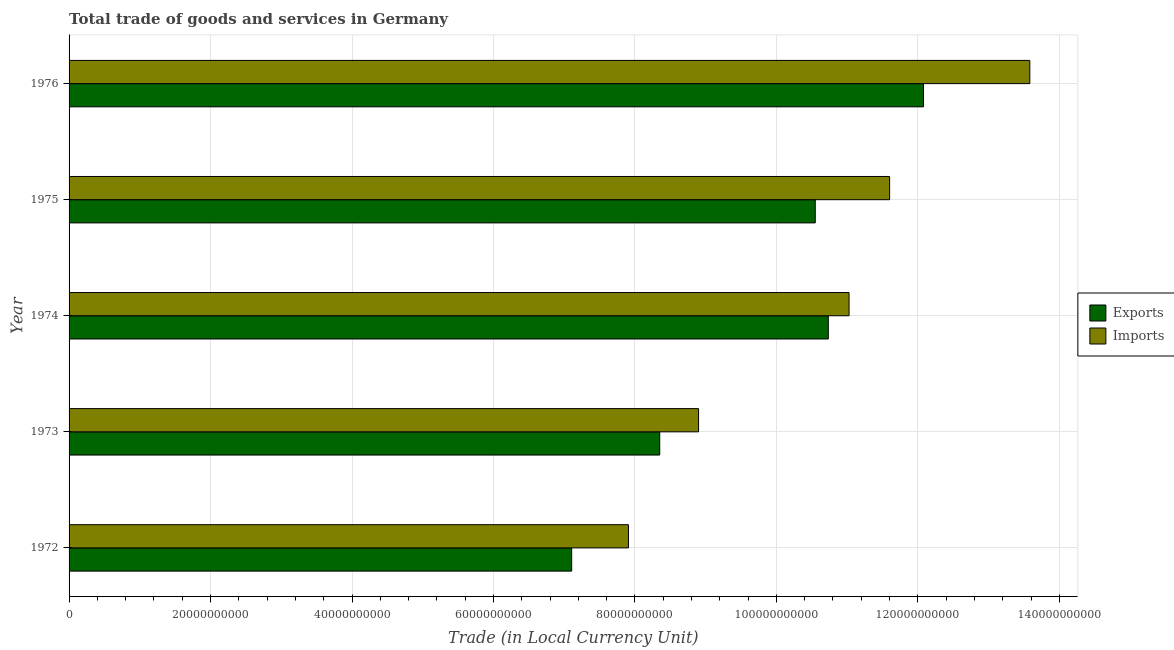How many different coloured bars are there?
Offer a terse response. 2. How many groups of bars are there?
Your answer should be very brief. 5. Are the number of bars on each tick of the Y-axis equal?
Ensure brevity in your answer.  Yes. What is the label of the 3rd group of bars from the top?
Keep it short and to the point. 1974. What is the imports of goods and services in 1974?
Keep it short and to the point. 1.10e+11. Across all years, what is the maximum imports of goods and services?
Give a very brief answer. 1.36e+11. Across all years, what is the minimum imports of goods and services?
Provide a succinct answer. 7.91e+1. In which year was the export of goods and services maximum?
Your answer should be very brief. 1976. What is the total export of goods and services in the graph?
Offer a very short reply. 4.88e+11. What is the difference between the export of goods and services in 1972 and that in 1974?
Your response must be concise. -3.63e+1. What is the difference between the export of goods and services in 1976 and the imports of goods and services in 1973?
Your answer should be compact. 3.18e+1. What is the average export of goods and services per year?
Your answer should be very brief. 9.76e+1. In the year 1976, what is the difference between the imports of goods and services and export of goods and services?
Offer a very short reply. 1.50e+1. In how many years, is the export of goods and services greater than 8000000000 LCU?
Your answer should be compact. 5. What is the ratio of the imports of goods and services in 1974 to that in 1976?
Offer a terse response. 0.81. Is the imports of goods and services in 1973 less than that in 1975?
Ensure brevity in your answer.  Yes. What is the difference between the highest and the second highest export of goods and services?
Keep it short and to the point. 1.35e+1. What is the difference between the highest and the lowest imports of goods and services?
Ensure brevity in your answer.  5.67e+1. What does the 2nd bar from the top in 1974 represents?
Provide a succinct answer. Exports. What does the 2nd bar from the bottom in 1976 represents?
Ensure brevity in your answer.  Imports. Are all the bars in the graph horizontal?
Make the answer very short. Yes. What is the difference between two consecutive major ticks on the X-axis?
Offer a very short reply. 2.00e+1. Does the graph contain any zero values?
Your answer should be compact. No. Where does the legend appear in the graph?
Give a very brief answer. Center right. How are the legend labels stacked?
Provide a short and direct response. Vertical. What is the title of the graph?
Offer a very short reply. Total trade of goods and services in Germany. Does "Merchandise exports" appear as one of the legend labels in the graph?
Keep it short and to the point. No. What is the label or title of the X-axis?
Your response must be concise. Trade (in Local Currency Unit). What is the Trade (in Local Currency Unit) of Exports in 1972?
Your answer should be compact. 7.11e+1. What is the Trade (in Local Currency Unit) in Imports in 1972?
Your answer should be very brief. 7.91e+1. What is the Trade (in Local Currency Unit) of Exports in 1973?
Your answer should be compact. 8.35e+1. What is the Trade (in Local Currency Unit) of Imports in 1973?
Your response must be concise. 8.90e+1. What is the Trade (in Local Currency Unit) of Exports in 1974?
Your answer should be compact. 1.07e+11. What is the Trade (in Local Currency Unit) in Imports in 1974?
Give a very brief answer. 1.10e+11. What is the Trade (in Local Currency Unit) in Exports in 1975?
Keep it short and to the point. 1.05e+11. What is the Trade (in Local Currency Unit) of Imports in 1975?
Keep it short and to the point. 1.16e+11. What is the Trade (in Local Currency Unit) in Exports in 1976?
Your answer should be compact. 1.21e+11. What is the Trade (in Local Currency Unit) of Imports in 1976?
Ensure brevity in your answer.  1.36e+11. Across all years, what is the maximum Trade (in Local Currency Unit) in Exports?
Offer a very short reply. 1.21e+11. Across all years, what is the maximum Trade (in Local Currency Unit) of Imports?
Your response must be concise. 1.36e+11. Across all years, what is the minimum Trade (in Local Currency Unit) of Exports?
Offer a very short reply. 7.11e+1. Across all years, what is the minimum Trade (in Local Currency Unit) of Imports?
Make the answer very short. 7.91e+1. What is the total Trade (in Local Currency Unit) in Exports in the graph?
Provide a succinct answer. 4.88e+11. What is the total Trade (in Local Currency Unit) in Imports in the graph?
Offer a terse response. 5.30e+11. What is the difference between the Trade (in Local Currency Unit) of Exports in 1972 and that in 1973?
Ensure brevity in your answer.  -1.24e+1. What is the difference between the Trade (in Local Currency Unit) of Imports in 1972 and that in 1973?
Provide a succinct answer. -9.91e+09. What is the difference between the Trade (in Local Currency Unit) of Exports in 1972 and that in 1974?
Give a very brief answer. -3.63e+1. What is the difference between the Trade (in Local Currency Unit) in Imports in 1972 and that in 1974?
Keep it short and to the point. -3.12e+1. What is the difference between the Trade (in Local Currency Unit) in Exports in 1972 and that in 1975?
Keep it short and to the point. -3.44e+1. What is the difference between the Trade (in Local Currency Unit) in Imports in 1972 and that in 1975?
Ensure brevity in your answer.  -3.69e+1. What is the difference between the Trade (in Local Currency Unit) in Exports in 1972 and that in 1976?
Your answer should be very brief. -4.97e+1. What is the difference between the Trade (in Local Currency Unit) of Imports in 1972 and that in 1976?
Your answer should be compact. -5.67e+1. What is the difference between the Trade (in Local Currency Unit) in Exports in 1973 and that in 1974?
Your answer should be very brief. -2.38e+1. What is the difference between the Trade (in Local Currency Unit) of Imports in 1973 and that in 1974?
Offer a very short reply. -2.13e+1. What is the difference between the Trade (in Local Currency Unit) in Exports in 1973 and that in 1975?
Offer a very short reply. -2.20e+1. What is the difference between the Trade (in Local Currency Unit) of Imports in 1973 and that in 1975?
Offer a terse response. -2.70e+1. What is the difference between the Trade (in Local Currency Unit) in Exports in 1973 and that in 1976?
Offer a terse response. -3.73e+1. What is the difference between the Trade (in Local Currency Unit) of Imports in 1973 and that in 1976?
Your answer should be very brief. -4.68e+1. What is the difference between the Trade (in Local Currency Unit) in Exports in 1974 and that in 1975?
Your answer should be very brief. 1.84e+09. What is the difference between the Trade (in Local Currency Unit) in Imports in 1974 and that in 1975?
Provide a succinct answer. -5.73e+09. What is the difference between the Trade (in Local Currency Unit) of Exports in 1974 and that in 1976?
Offer a very short reply. -1.35e+1. What is the difference between the Trade (in Local Currency Unit) of Imports in 1974 and that in 1976?
Ensure brevity in your answer.  -2.56e+1. What is the difference between the Trade (in Local Currency Unit) of Exports in 1975 and that in 1976?
Offer a very short reply. -1.53e+1. What is the difference between the Trade (in Local Currency Unit) in Imports in 1975 and that in 1976?
Ensure brevity in your answer.  -1.98e+1. What is the difference between the Trade (in Local Currency Unit) in Exports in 1972 and the Trade (in Local Currency Unit) in Imports in 1973?
Your answer should be compact. -1.79e+1. What is the difference between the Trade (in Local Currency Unit) of Exports in 1972 and the Trade (in Local Currency Unit) of Imports in 1974?
Your response must be concise. -3.92e+1. What is the difference between the Trade (in Local Currency Unit) of Exports in 1972 and the Trade (in Local Currency Unit) of Imports in 1975?
Give a very brief answer. -4.50e+1. What is the difference between the Trade (in Local Currency Unit) of Exports in 1972 and the Trade (in Local Currency Unit) of Imports in 1976?
Your answer should be very brief. -6.48e+1. What is the difference between the Trade (in Local Currency Unit) of Exports in 1973 and the Trade (in Local Currency Unit) of Imports in 1974?
Give a very brief answer. -2.68e+1. What is the difference between the Trade (in Local Currency Unit) of Exports in 1973 and the Trade (in Local Currency Unit) of Imports in 1975?
Make the answer very short. -3.25e+1. What is the difference between the Trade (in Local Currency Unit) in Exports in 1973 and the Trade (in Local Currency Unit) in Imports in 1976?
Your answer should be compact. -5.23e+1. What is the difference between the Trade (in Local Currency Unit) of Exports in 1974 and the Trade (in Local Currency Unit) of Imports in 1975?
Make the answer very short. -8.67e+09. What is the difference between the Trade (in Local Currency Unit) of Exports in 1974 and the Trade (in Local Currency Unit) of Imports in 1976?
Offer a terse response. -2.85e+1. What is the difference between the Trade (in Local Currency Unit) of Exports in 1975 and the Trade (in Local Currency Unit) of Imports in 1976?
Give a very brief answer. -3.03e+1. What is the average Trade (in Local Currency Unit) in Exports per year?
Your answer should be very brief. 9.76e+1. What is the average Trade (in Local Currency Unit) in Imports per year?
Provide a succinct answer. 1.06e+11. In the year 1972, what is the difference between the Trade (in Local Currency Unit) in Exports and Trade (in Local Currency Unit) in Imports?
Offer a very short reply. -8.03e+09. In the year 1973, what is the difference between the Trade (in Local Currency Unit) in Exports and Trade (in Local Currency Unit) in Imports?
Keep it short and to the point. -5.49e+09. In the year 1974, what is the difference between the Trade (in Local Currency Unit) of Exports and Trade (in Local Currency Unit) of Imports?
Give a very brief answer. -2.94e+09. In the year 1975, what is the difference between the Trade (in Local Currency Unit) in Exports and Trade (in Local Currency Unit) in Imports?
Your answer should be compact. -1.05e+1. In the year 1976, what is the difference between the Trade (in Local Currency Unit) of Exports and Trade (in Local Currency Unit) of Imports?
Give a very brief answer. -1.50e+1. What is the ratio of the Trade (in Local Currency Unit) in Exports in 1972 to that in 1973?
Make the answer very short. 0.85. What is the ratio of the Trade (in Local Currency Unit) in Imports in 1972 to that in 1973?
Your answer should be compact. 0.89. What is the ratio of the Trade (in Local Currency Unit) of Exports in 1972 to that in 1974?
Your response must be concise. 0.66. What is the ratio of the Trade (in Local Currency Unit) in Imports in 1972 to that in 1974?
Your answer should be very brief. 0.72. What is the ratio of the Trade (in Local Currency Unit) in Exports in 1972 to that in 1975?
Keep it short and to the point. 0.67. What is the ratio of the Trade (in Local Currency Unit) of Imports in 1972 to that in 1975?
Offer a very short reply. 0.68. What is the ratio of the Trade (in Local Currency Unit) of Exports in 1972 to that in 1976?
Offer a very short reply. 0.59. What is the ratio of the Trade (in Local Currency Unit) in Imports in 1972 to that in 1976?
Your answer should be very brief. 0.58. What is the ratio of the Trade (in Local Currency Unit) of Exports in 1973 to that in 1974?
Give a very brief answer. 0.78. What is the ratio of the Trade (in Local Currency Unit) of Imports in 1973 to that in 1974?
Your answer should be very brief. 0.81. What is the ratio of the Trade (in Local Currency Unit) of Exports in 1973 to that in 1975?
Make the answer very short. 0.79. What is the ratio of the Trade (in Local Currency Unit) of Imports in 1973 to that in 1975?
Make the answer very short. 0.77. What is the ratio of the Trade (in Local Currency Unit) in Exports in 1973 to that in 1976?
Ensure brevity in your answer.  0.69. What is the ratio of the Trade (in Local Currency Unit) of Imports in 1973 to that in 1976?
Give a very brief answer. 0.66. What is the ratio of the Trade (in Local Currency Unit) in Exports in 1974 to that in 1975?
Your answer should be very brief. 1.02. What is the ratio of the Trade (in Local Currency Unit) of Imports in 1974 to that in 1975?
Your answer should be very brief. 0.95. What is the ratio of the Trade (in Local Currency Unit) of Exports in 1974 to that in 1976?
Provide a short and direct response. 0.89. What is the ratio of the Trade (in Local Currency Unit) of Imports in 1974 to that in 1976?
Provide a short and direct response. 0.81. What is the ratio of the Trade (in Local Currency Unit) of Exports in 1975 to that in 1976?
Keep it short and to the point. 0.87. What is the ratio of the Trade (in Local Currency Unit) in Imports in 1975 to that in 1976?
Ensure brevity in your answer.  0.85. What is the difference between the highest and the second highest Trade (in Local Currency Unit) in Exports?
Provide a short and direct response. 1.35e+1. What is the difference between the highest and the second highest Trade (in Local Currency Unit) of Imports?
Make the answer very short. 1.98e+1. What is the difference between the highest and the lowest Trade (in Local Currency Unit) in Exports?
Your answer should be compact. 4.97e+1. What is the difference between the highest and the lowest Trade (in Local Currency Unit) of Imports?
Your response must be concise. 5.67e+1. 